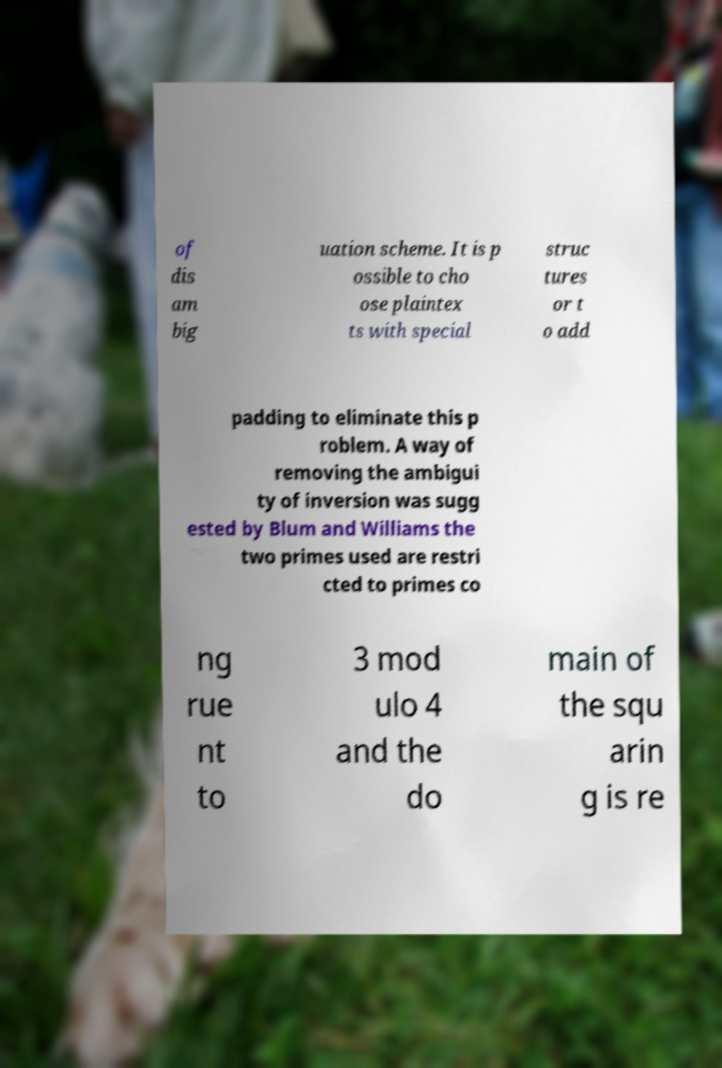Can you read and provide the text displayed in the image?This photo seems to have some interesting text. Can you extract and type it out for me? of dis am big uation scheme. It is p ossible to cho ose plaintex ts with special struc tures or t o add padding to eliminate this p roblem. A way of removing the ambigui ty of inversion was sugg ested by Blum and Williams the two primes used are restri cted to primes co ng rue nt to 3 mod ulo 4 and the do main of the squ arin g is re 